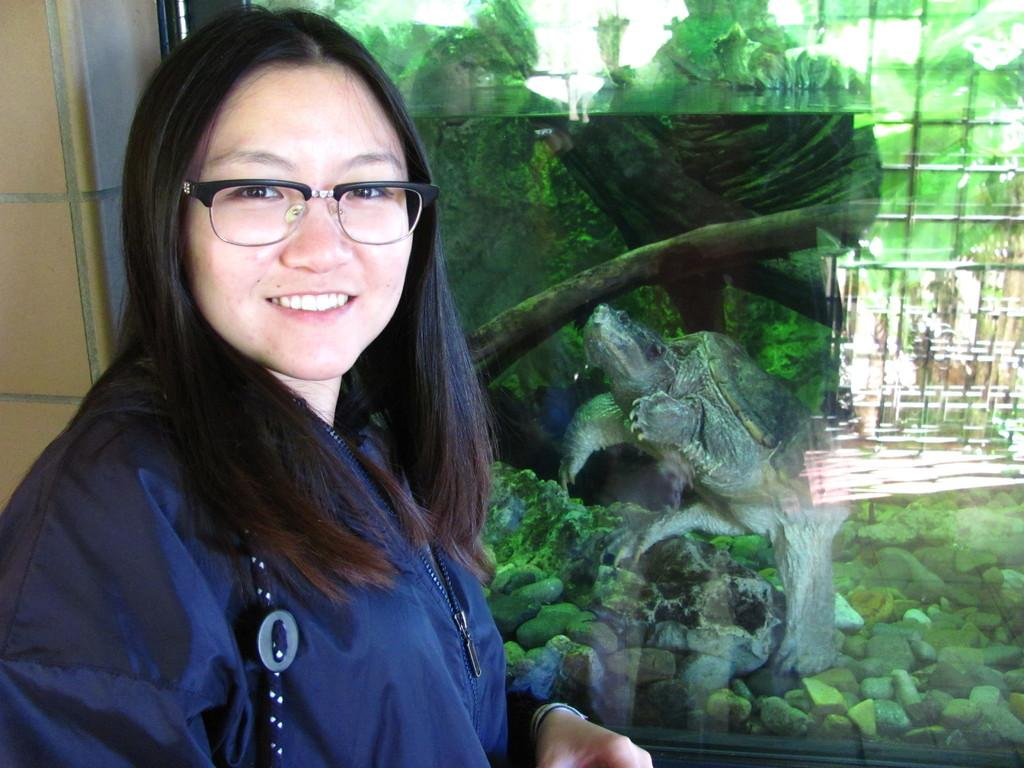Who is present in the image? There is a woman in the image. What is the woman wearing? The woman is wearing a blue dress and specs. What is the woman's facial expression? The woman is smiling. What can be seen in the background of the image? There is a turtle and stones in the background of the image. What type of branch is the woman holding in the image? There is no branch present in the image. How many volleyballs are visible in the image? There are no volleyballs present in the image. 